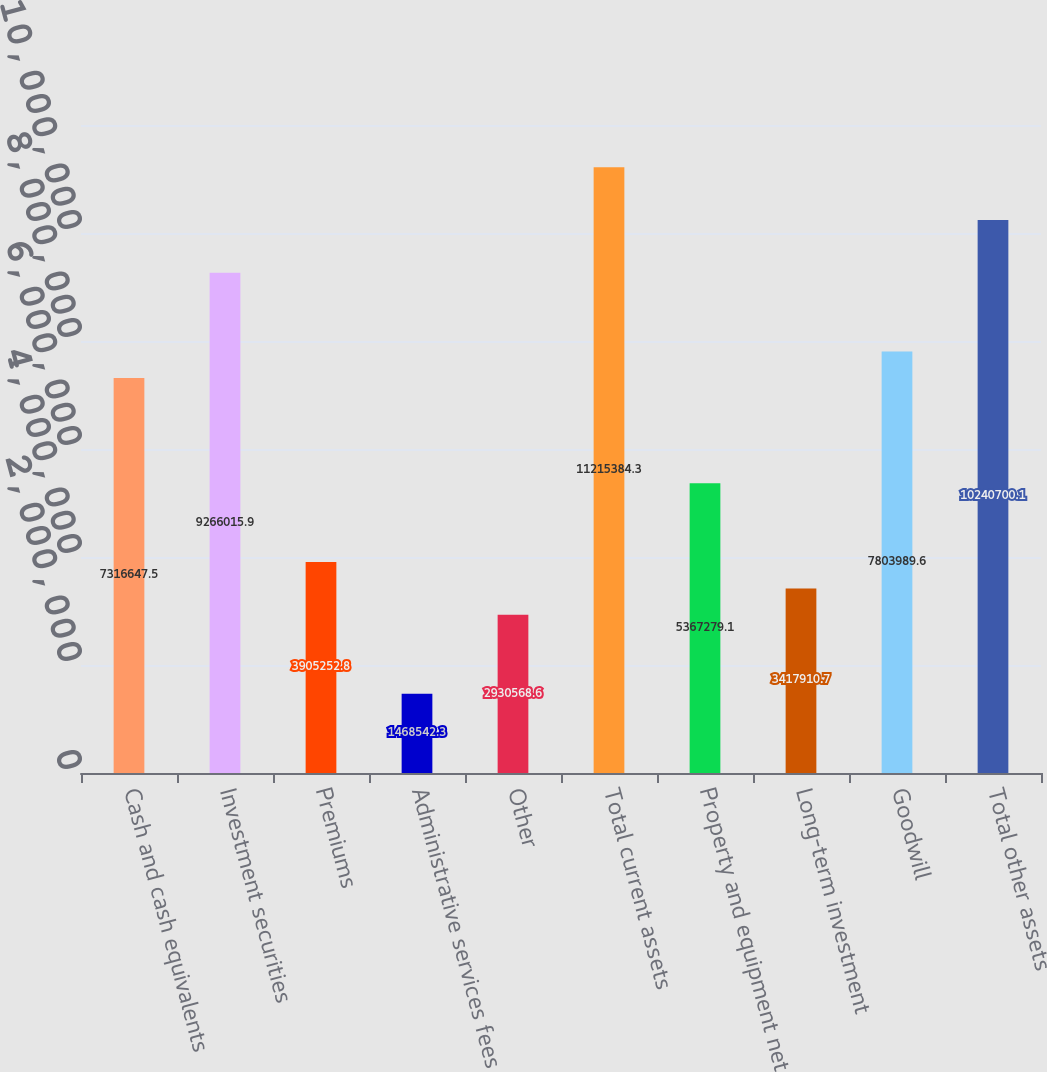Convert chart to OTSL. <chart><loc_0><loc_0><loc_500><loc_500><bar_chart><fcel>Cash and cash equivalents<fcel>Investment securities<fcel>Premiums<fcel>Administrative services fees<fcel>Other<fcel>Total current assets<fcel>Property and equipment net<fcel>Long-term investment<fcel>Goodwill<fcel>Total other assets<nl><fcel>7.31665e+06<fcel>9.26602e+06<fcel>3.90525e+06<fcel>1.46854e+06<fcel>2.93057e+06<fcel>1.12154e+07<fcel>5.36728e+06<fcel>3.41791e+06<fcel>7.80399e+06<fcel>1.02407e+07<nl></chart> 